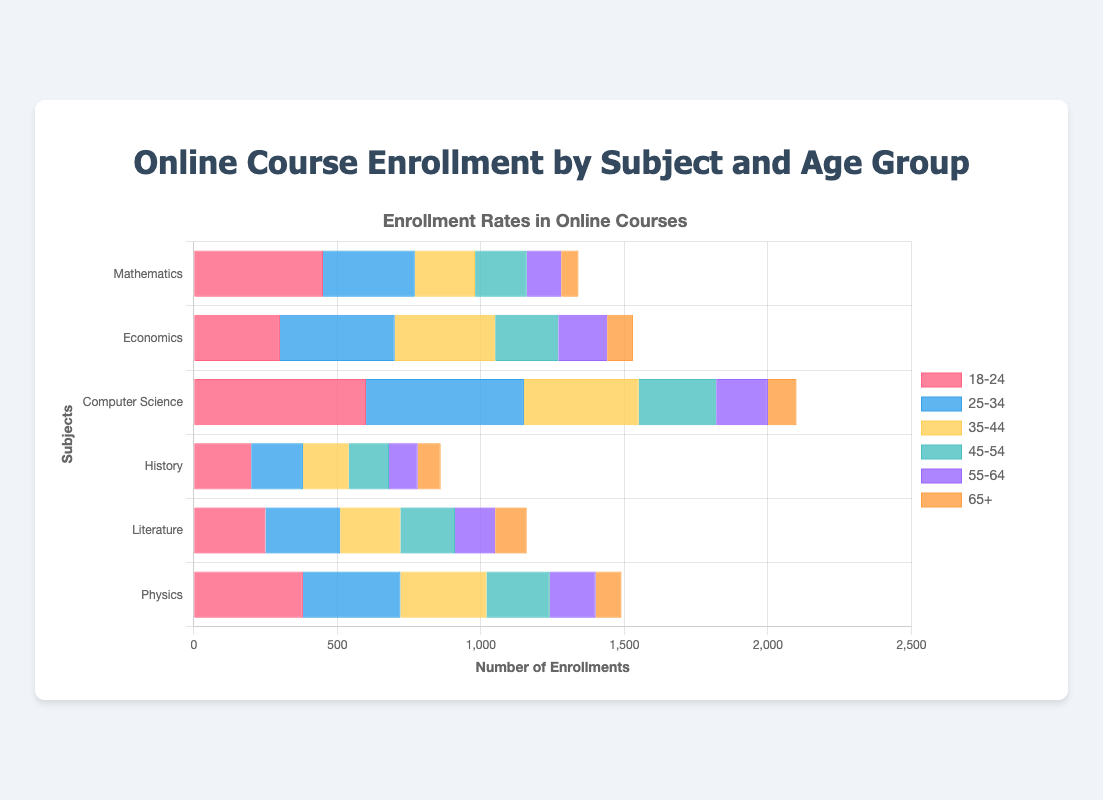Which subject had the highest total enrollment across all age groups? To find the subject with the highest total enrollment, sum the enrollments for each subject across all age groups. Compare these sums to identify the highest: Mathematics (450+320+210+180+120+60=1340), Economics (300+400+350+220+170+90=1530), Computer Science (600+550+400+270+180+100=2100), History (200+180+160+140+100+80=860), Literature (250+260+210+190+140+110=1160), Physics (380+340+300+220+160+90=1490). Hence, Computer Science has the highest total enrollment.
Answer: Computer Science Which age group had the highest enrollment in Mathematics? Evaluate the enrollments for each age group in Mathematics: 18-24 (450), 25-34 (320), 35-44 (210), 45-54 (180), 55-64 (120), 65+ (60). The 18-24 age group has the highest enrollment in Mathematics.
Answer: 18-24 Compare the enrollment of "18-24" and "65+" age groups in Physics. Review the enrollment numbers for the 18-24 (380) and 65+ (90) age groups in Physics. The 18-24 age group has a higher enrollment than the 65+ age group.
Answer: 18-24 What is the combined enrollment for Literature and History among the 35-44 age group? Summing the enrollments in Literature (210) and History (160) for the 35-44 age group results in 210 + 160 = 370.
Answer: 370 Which subject shows the largest difference in enrollment between the age groups 18-24 and 25-34? Calculate the differences in enrollment between age groups 18-24 and 25-34 for each subject: Mathematics (450-320=130), Economics (300-400=-100), Computer Science (600-550=50), History (200-180=20), Literature (250-260=-10), Physics (380-340=40). The largest difference is in Mathematics (130).
Answer: Mathematics Which subject has the lowest enrollment among the 65+ age group? Compare the enrollment numbers for the 65+ age group across all subjects: Mathematics (60), Economics (90), Computer Science (100), History (80), Literature (110), Physics (90). Mathematics has the lowest enrollment in the 65+ age group.
Answer: Mathematics What is the average enrollment of Economics across all age groups? Sum the enrollments for Economics: 300, 400, 350, 220, 170, 90 which adds up to 1530. Divide by the number of age groups (6), so 1530 / 6 = 255.
Answer: 255 How does the total enrollment for Computer Science (all age groups combined) compare to the total enrollment for Physics? Calculate the total enrollments: Computer Science (600+550+400+270+180+100=2100) and Physics (380+340+300+220+160+90=1490). Computer Science has a higher total enrollment than Physics.
Answer: Computer Science What is the median enrollment figure for History across all age groups? List the enrollments for History in ascending order: 80, 100, 140, 160, 180, 200. The median is the average of the middle two values (140 and 160), which is (140+160)/2 = 150.
Answer: 150 